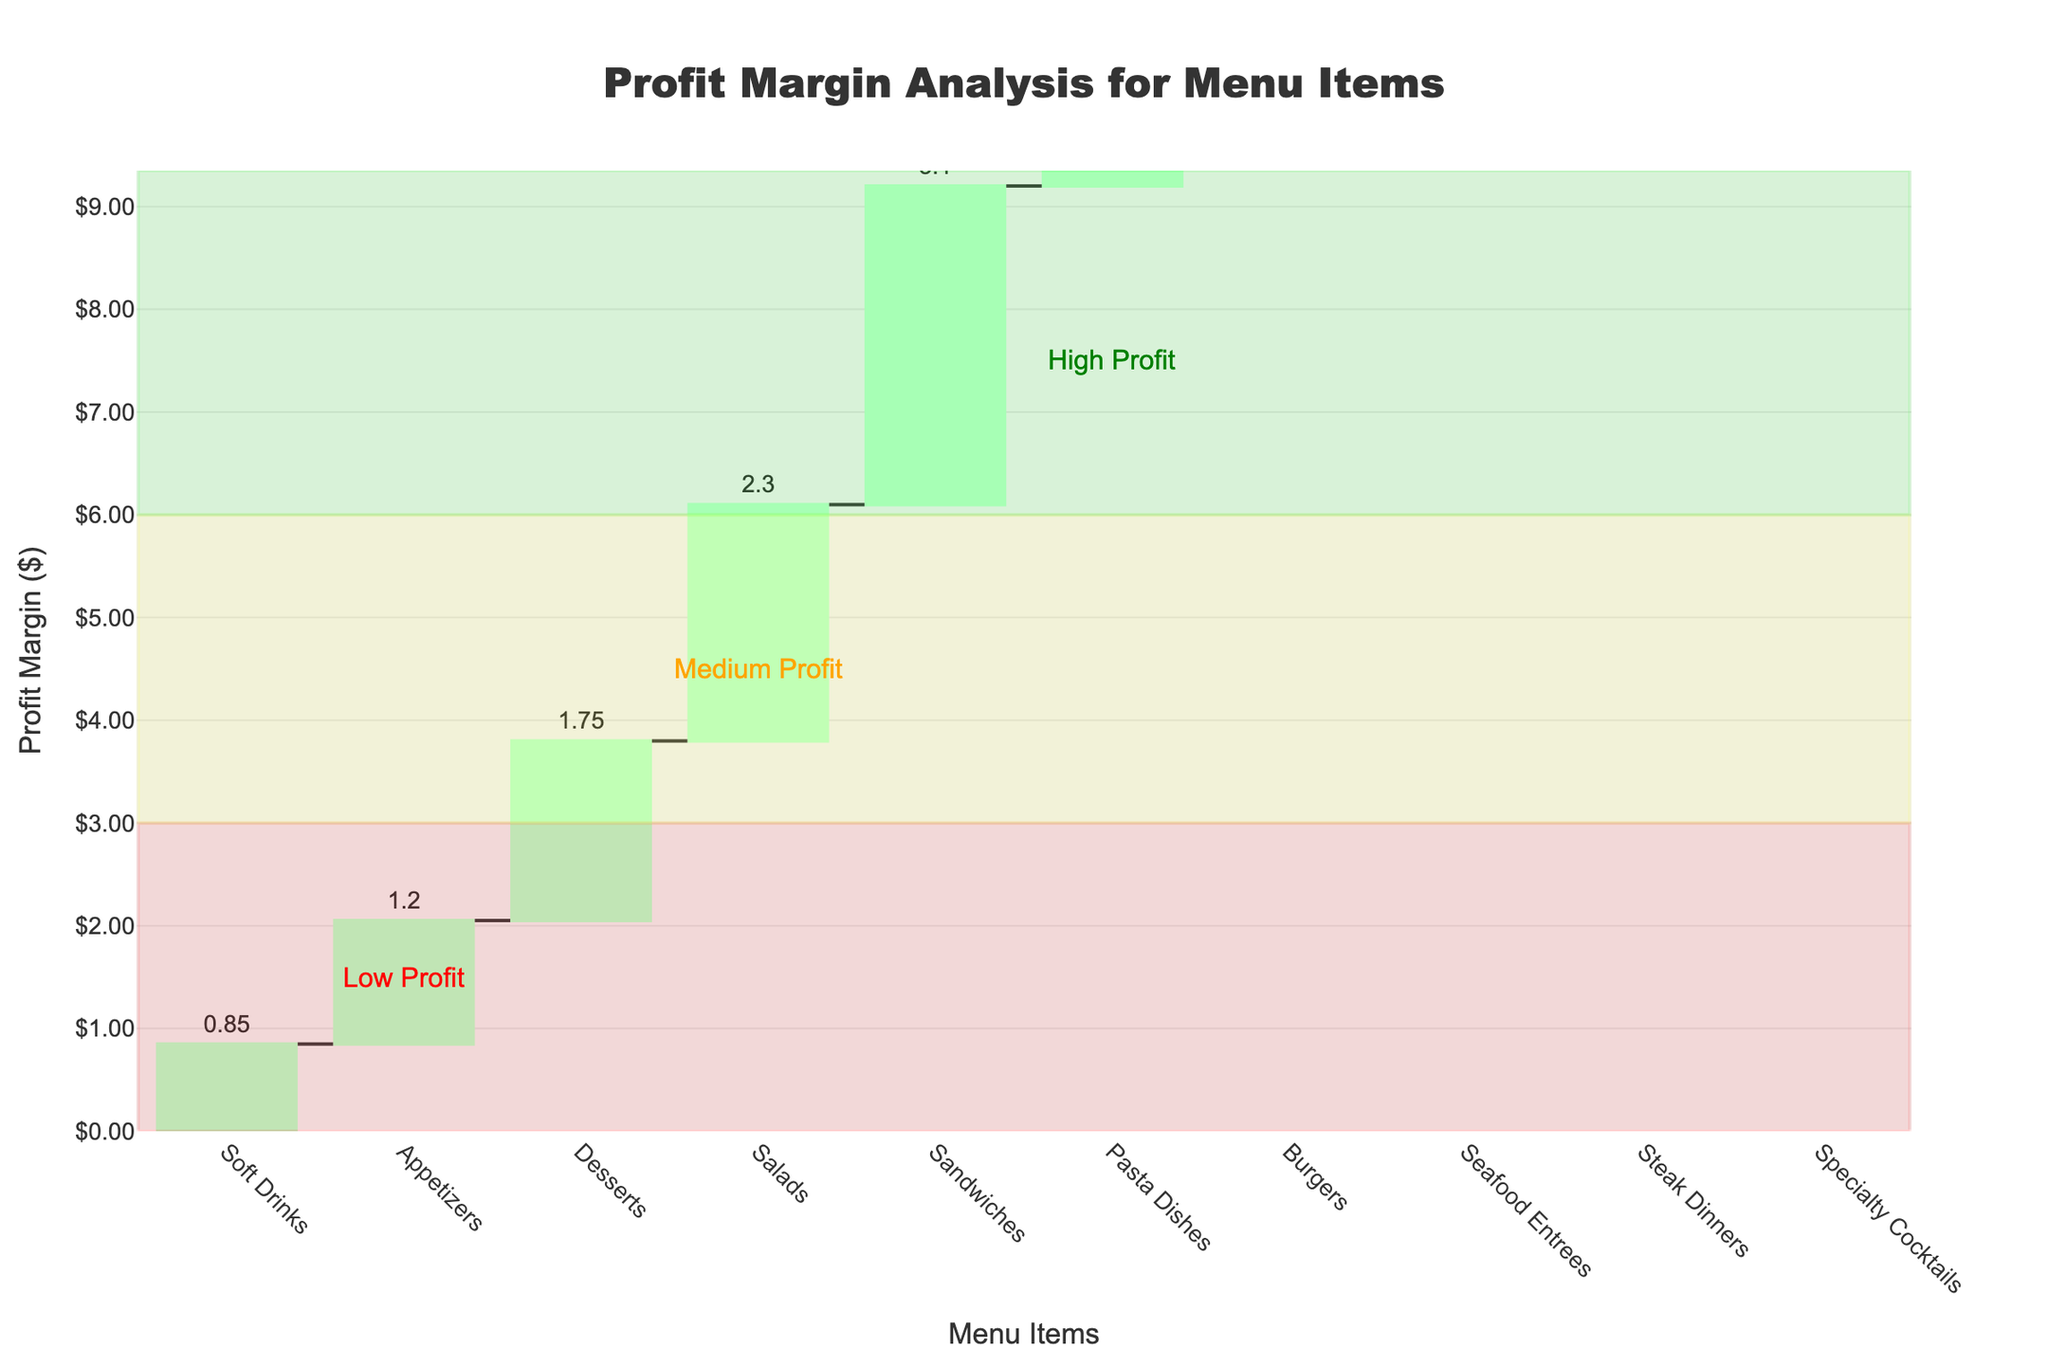What is the title of the Waterfall Chart? The title is located at the top center of the chart and provides an overview of what the chart represents. In this case, it clearly states the focus of the analysis.
Answer: Profit Margin Analysis for Menu Items How many menu items are analyzed in the chart? Count the total number of bars/items listed along the x-axis to determine the number of menu items analyzed.
Answer: 10 Which menu item has the highest profit margin? Locate the tallest bar on the chart, which signifies the highest profit margin among the menu items.
Answer: Specialty Cocktails What is the profit margin of Burgers? Find the bar labeled "Burgers" on the x-axis and read the value indicated at the top of the bar to know the profit margin.
Answer: 4.25 How much higher is the profit margin of Steak Dinners compared to Sandwiches? Identify the profit margins of both Steak Dinners and Sandwiches. Then, subtract the profit margin of Sandwiches from that of Steak Dinners. (7.20 - 3.10)
Answer: 4.10 Which menu items fall under the 'High Profit' category? Look for annotations or labels in the chart that categorize the profit ranges and identify which menu items fall within the 'High Profit' section (above 6).
Answer: Seafood Entrees, Steak Dinners, Specialty Cocktails What is the combined profit margin of Appetizers and Desserts? Identify the profit margins of both Appetizers and Desserts. Then, add these values together. (1.20 + 1.75)
Answer: 2.95 Which menu item has the lowest profit margin, and what is its value? Locate the shortest bar on the chart, which signifies the lowest profit margin among the menu items. Read the value indicated at the top of this bar.
Answer: Soft Drinks, 0.85 Is the profit margin of Pasta Dishes higher or lower than that of Sandwiches? Compare the bars for Pasta Dishes and Sandwiches based on their heights and values to determine which is higher.
Answer: Higher How many items are in the 'Medium Profit' category, and what is their range? Look for annotations or labels that categorize the profit ranges and count the number of items falling within the 'Medium Profit' section (3 to 6). Additionally, specify the profit margin range.
Answer: 3 items, profit margin between 3 and 6 